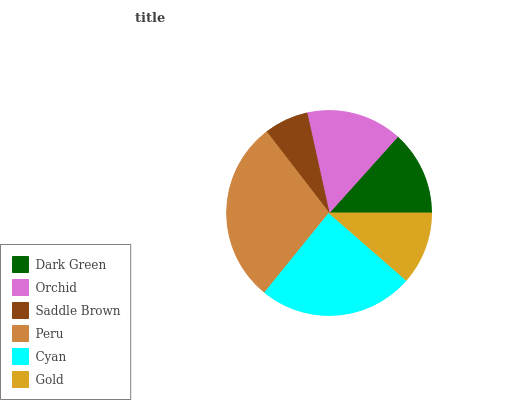Is Saddle Brown the minimum?
Answer yes or no. Yes. Is Peru the maximum?
Answer yes or no. Yes. Is Orchid the minimum?
Answer yes or no. No. Is Orchid the maximum?
Answer yes or no. No. Is Orchid greater than Dark Green?
Answer yes or no. Yes. Is Dark Green less than Orchid?
Answer yes or no. Yes. Is Dark Green greater than Orchid?
Answer yes or no. No. Is Orchid less than Dark Green?
Answer yes or no. No. Is Orchid the high median?
Answer yes or no. Yes. Is Dark Green the low median?
Answer yes or no. Yes. Is Peru the high median?
Answer yes or no. No. Is Orchid the low median?
Answer yes or no. No. 